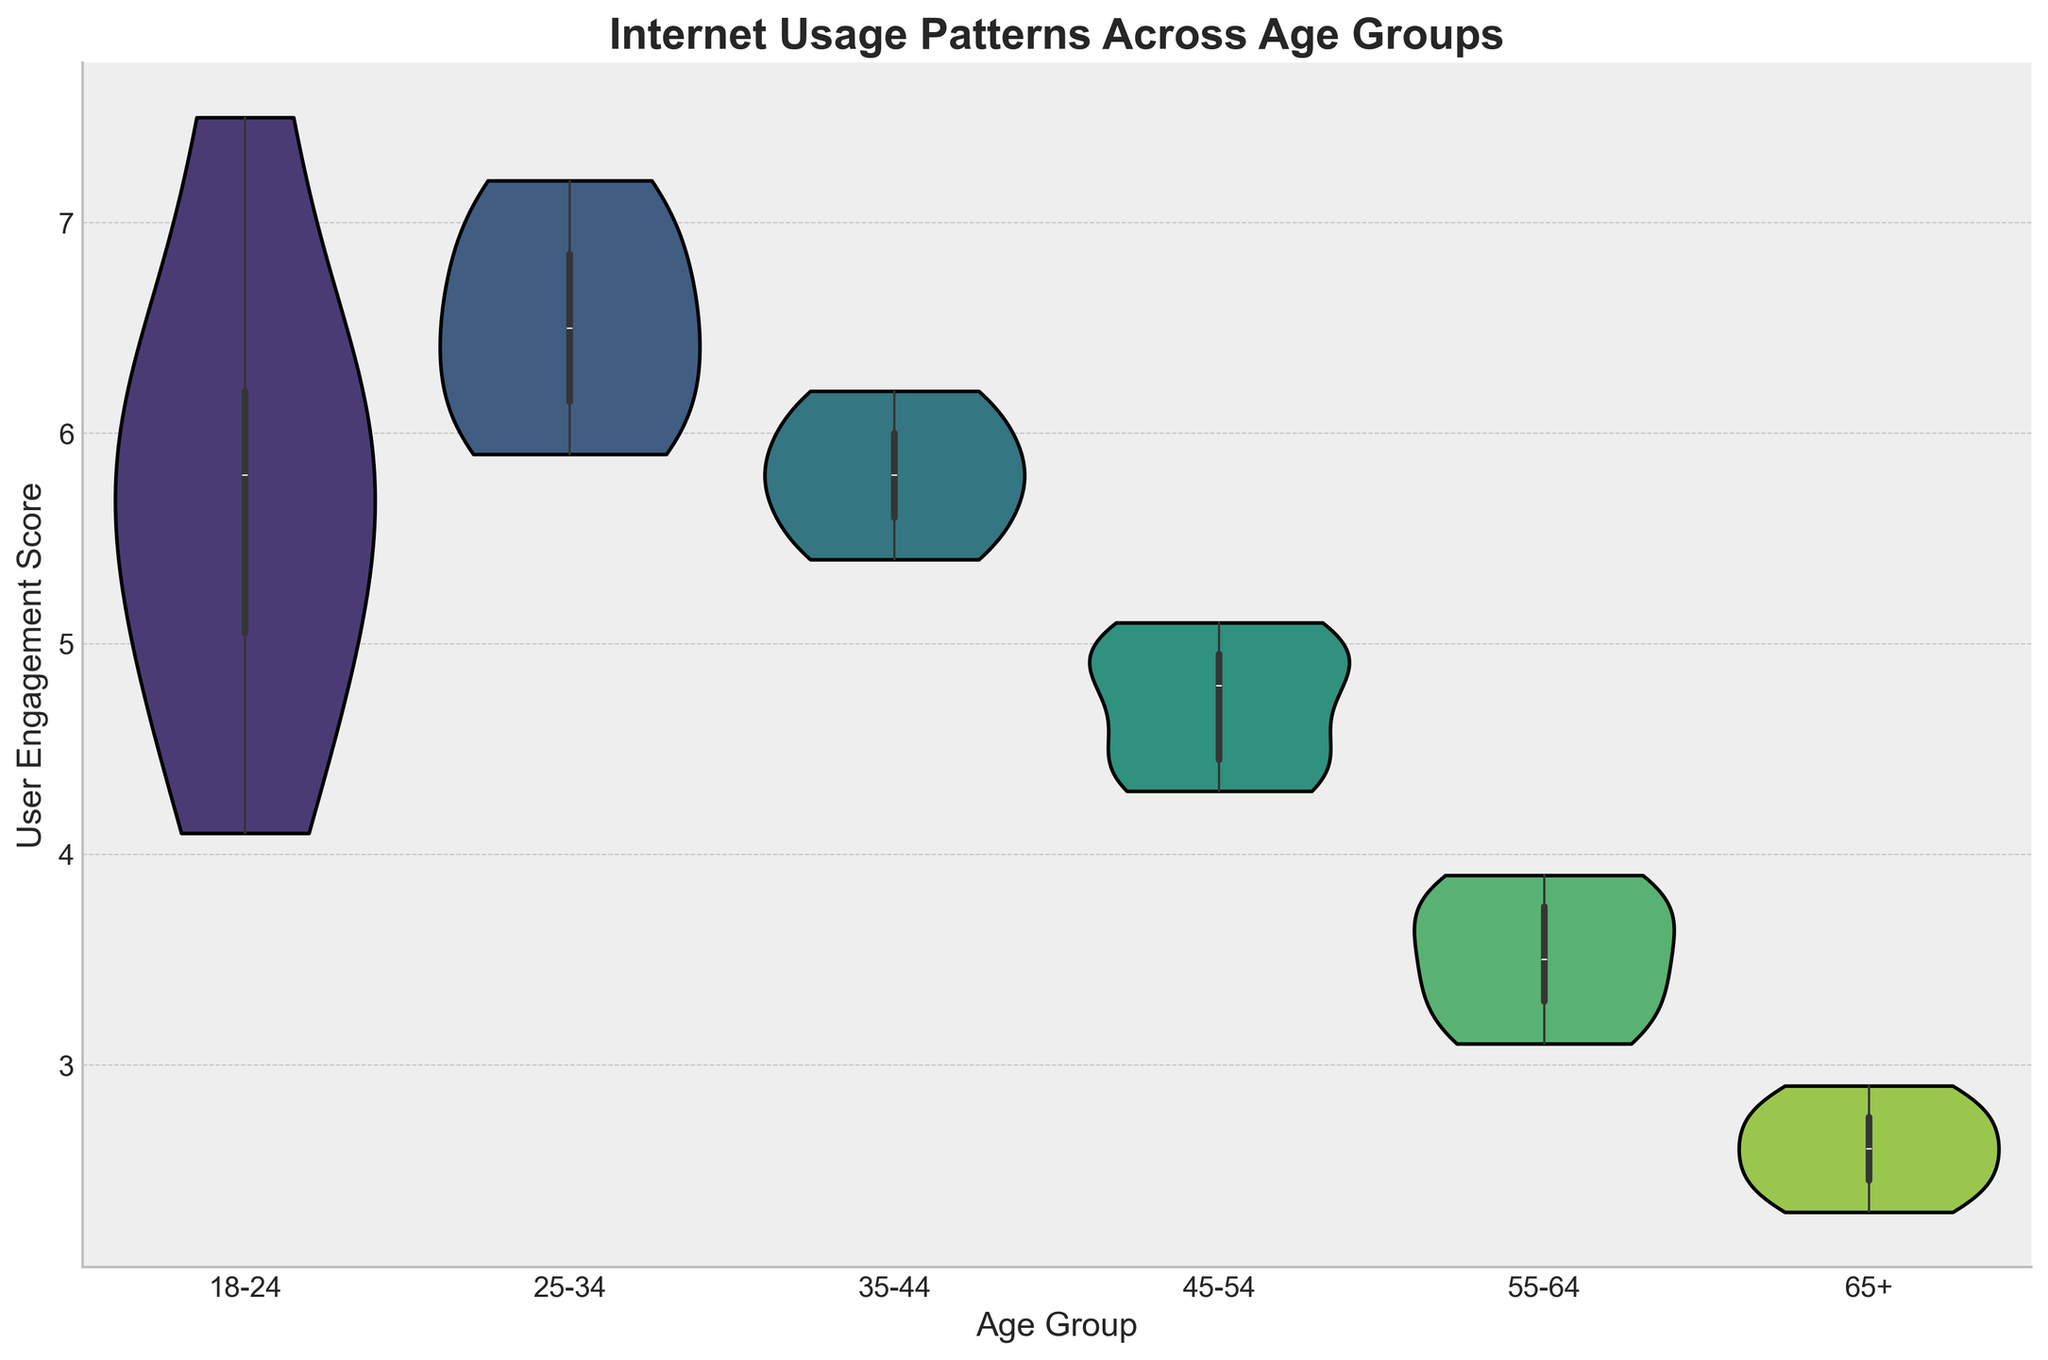What is the title of the figure? The title is located at the top of the figure and is bold and large, indicating the main idea of the visualization.
Answer: Internet Usage Patterns Across Age Groups What do the x-axis and y-axis represent in the figure? The x-axis represents different age groups, and the y-axis represents the user engagement score. This can be identified by reading the labels on the axes.
Answer: The x-axis represents Age Group, and the y-axis represents User Engagement Score Which age group has the highest median user engagement score? In a violin plot, the median value is typically indicated by the white dot or a line within each violin shape. By visually inspecting each group, we see that the 25-34 age group has the highest median value.
Answer: 25-34 Which age group shows the widest range of user engagement scores? The range of user engagement scores is shown by the vertical length of each violin plot. The wider the spread, the larger the range. The 18-24 age group has the widest range.
Answer: 18-24 What's the approximate median user engagement score for the age group 35-44? The median value can be estimated as the central point within the violin for the 35-44 age group. The value appears around 5.8.
Answer: Approximately 5.8 Compare the user engagement score distributions for the 45-54 and 55-64 age groups. Which has a higher average user engagement score? By looking at the central tendency of the distribution, the 45-54 age group has a higher user engagement score on average compared to the 55-64 age group.
Answer: 45-54 Is there evidence that user engagement tends to decrease with age? By examining the median and the overall spread of the violins across age groups, you can see that both median and ranges of scores decrease progressively with older age groups.
Answer: Yes Are the distributions of user engagement scores for the age groups 65+ and 55-64 similar? The distributions can be compared by their shapes and spread. Both age groups have a lower user engagement score with a very narrow range, indicating they are fairly similar.
Answer: Yes What kind of inner representation is used within the violin plots to show the data distribution? The inside of the violin plots uses box plots, which can be identified by the box shapes within the violins that illustrate the IQR, median, and potential outliers.
Answer: Box plots 